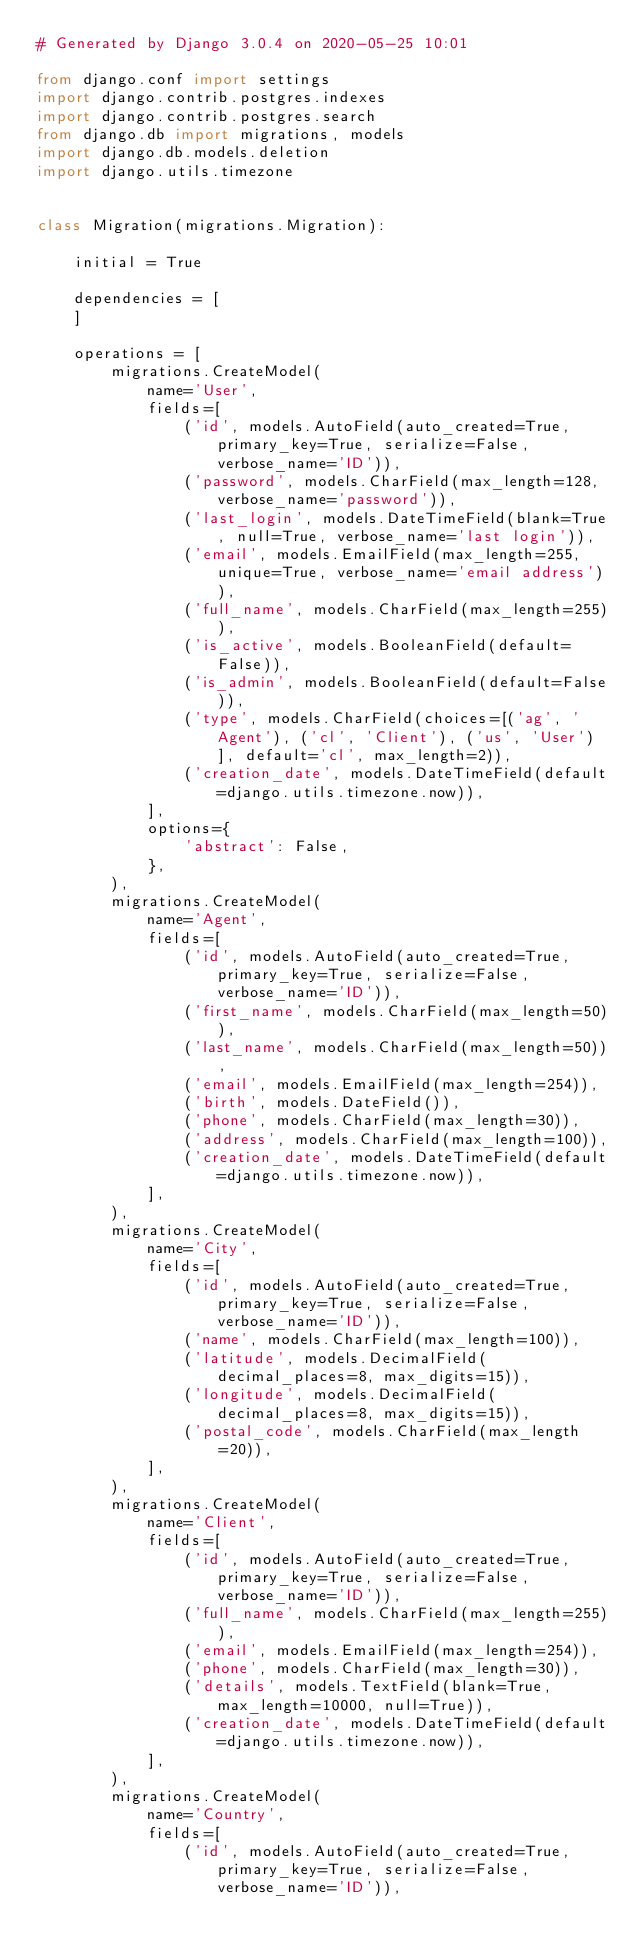<code> <loc_0><loc_0><loc_500><loc_500><_Python_># Generated by Django 3.0.4 on 2020-05-25 10:01

from django.conf import settings
import django.contrib.postgres.indexes
import django.contrib.postgres.search
from django.db import migrations, models
import django.db.models.deletion
import django.utils.timezone


class Migration(migrations.Migration):

    initial = True

    dependencies = [
    ]

    operations = [
        migrations.CreateModel(
            name='User',
            fields=[
                ('id', models.AutoField(auto_created=True, primary_key=True, serialize=False, verbose_name='ID')),
                ('password', models.CharField(max_length=128, verbose_name='password')),
                ('last_login', models.DateTimeField(blank=True, null=True, verbose_name='last login')),
                ('email', models.EmailField(max_length=255, unique=True, verbose_name='email address')),
                ('full_name', models.CharField(max_length=255)),
                ('is_active', models.BooleanField(default=False)),
                ('is_admin', models.BooleanField(default=False)),
                ('type', models.CharField(choices=[('ag', 'Agent'), ('cl', 'Client'), ('us', 'User')], default='cl', max_length=2)),
                ('creation_date', models.DateTimeField(default=django.utils.timezone.now)),
            ],
            options={
                'abstract': False,
            },
        ),
        migrations.CreateModel(
            name='Agent',
            fields=[
                ('id', models.AutoField(auto_created=True, primary_key=True, serialize=False, verbose_name='ID')),
                ('first_name', models.CharField(max_length=50)),
                ('last_name', models.CharField(max_length=50)),
                ('email', models.EmailField(max_length=254)),
                ('birth', models.DateField()),
                ('phone', models.CharField(max_length=30)),
                ('address', models.CharField(max_length=100)),
                ('creation_date', models.DateTimeField(default=django.utils.timezone.now)),
            ],
        ),
        migrations.CreateModel(
            name='City',
            fields=[
                ('id', models.AutoField(auto_created=True, primary_key=True, serialize=False, verbose_name='ID')),
                ('name', models.CharField(max_length=100)),
                ('latitude', models.DecimalField(decimal_places=8, max_digits=15)),
                ('longitude', models.DecimalField(decimal_places=8, max_digits=15)),
                ('postal_code', models.CharField(max_length=20)),
            ],
        ),
        migrations.CreateModel(
            name='Client',
            fields=[
                ('id', models.AutoField(auto_created=True, primary_key=True, serialize=False, verbose_name='ID')),
                ('full_name', models.CharField(max_length=255)),
                ('email', models.EmailField(max_length=254)),
                ('phone', models.CharField(max_length=30)),
                ('details', models.TextField(blank=True, max_length=10000, null=True)),
                ('creation_date', models.DateTimeField(default=django.utils.timezone.now)),
            ],
        ),
        migrations.CreateModel(
            name='Country',
            fields=[
                ('id', models.AutoField(auto_created=True, primary_key=True, serialize=False, verbose_name='ID')),</code> 